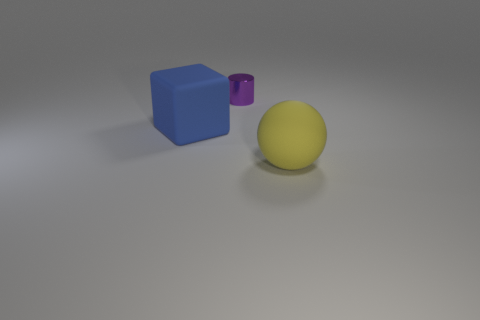If this image is part of a larger story, what do you think precedes or follows this scene? If the image were part of a larger narrative, it might precede a scenario in which these objects are used for a purpose, such as components in a physics demonstration about shapes and volumes. Alternatively, it might follow a scene where the objects were used in an educational setting, and someone has just cleared a table, leaving only these items behind. 